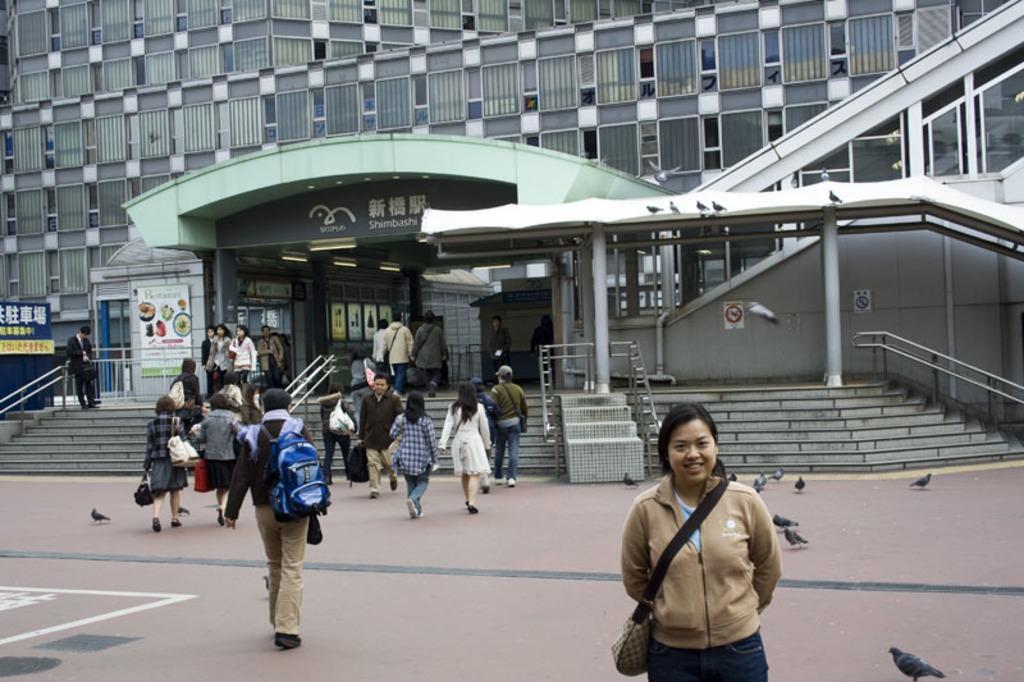Can you describe this image briefly? In this image, we can see a group of people. Few are standing and walking. Here a woman is wearing a bag, sewing and smiling. Background there is a building, stairs, rods, glass, banners, pillars. Few birds on the platform. 